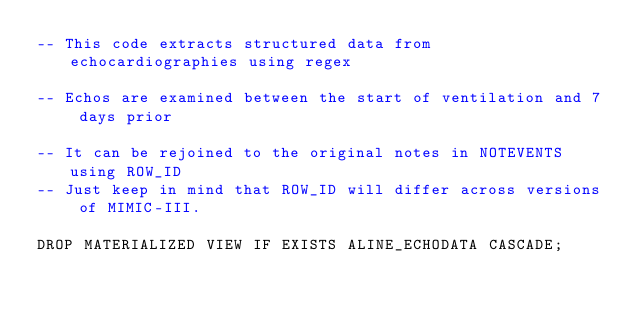<code> <loc_0><loc_0><loc_500><loc_500><_SQL_>-- This code extracts structured data from echocardiographies using regex

-- Echos are examined between the start of ventilation and 7 days prior

-- It can be rejoined to the original notes in NOTEVENTS using ROW_ID
-- Just keep in mind that ROW_ID will differ across versions of MIMIC-III.

DROP MATERIALIZED VIEW IF EXISTS ALINE_ECHODATA CASCADE;</code> 